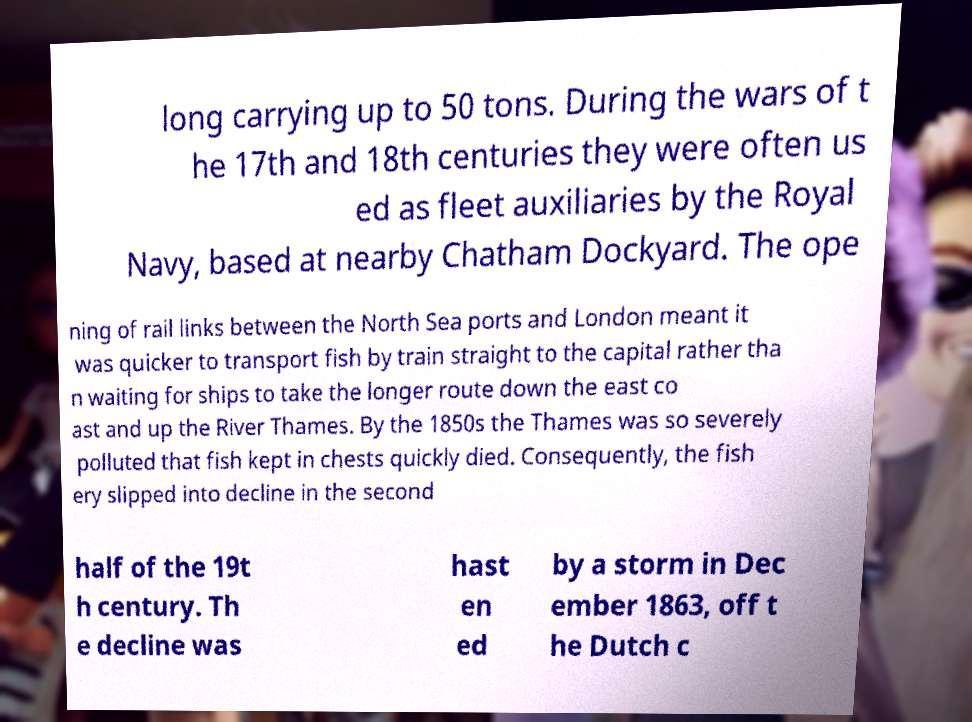Can you read and provide the text displayed in the image?This photo seems to have some interesting text. Can you extract and type it out for me? long carrying up to 50 tons. During the wars of t he 17th and 18th centuries they were often us ed as fleet auxiliaries by the Royal Navy, based at nearby Chatham Dockyard. The ope ning of rail links between the North Sea ports and London meant it was quicker to transport fish by train straight to the capital rather tha n waiting for ships to take the longer route down the east co ast and up the River Thames. By the 1850s the Thames was so severely polluted that fish kept in chests quickly died. Consequently, the fish ery slipped into decline in the second half of the 19t h century. Th e decline was hast en ed by a storm in Dec ember 1863, off t he Dutch c 